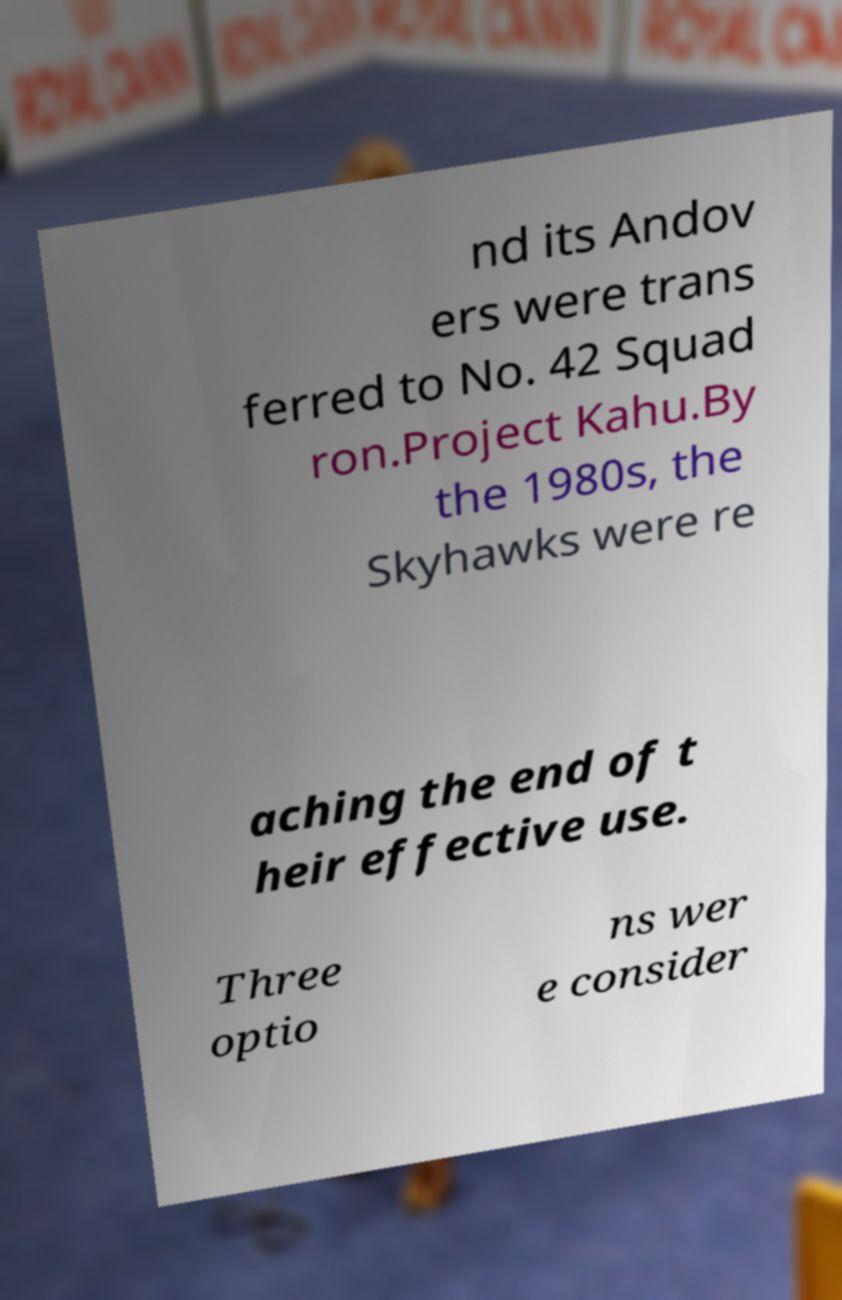What messages or text are displayed in this image? I need them in a readable, typed format. nd its Andov ers were trans ferred to No. 42 Squad ron.Project Kahu.By the 1980s, the Skyhawks were re aching the end of t heir effective use. Three optio ns wer e consider 